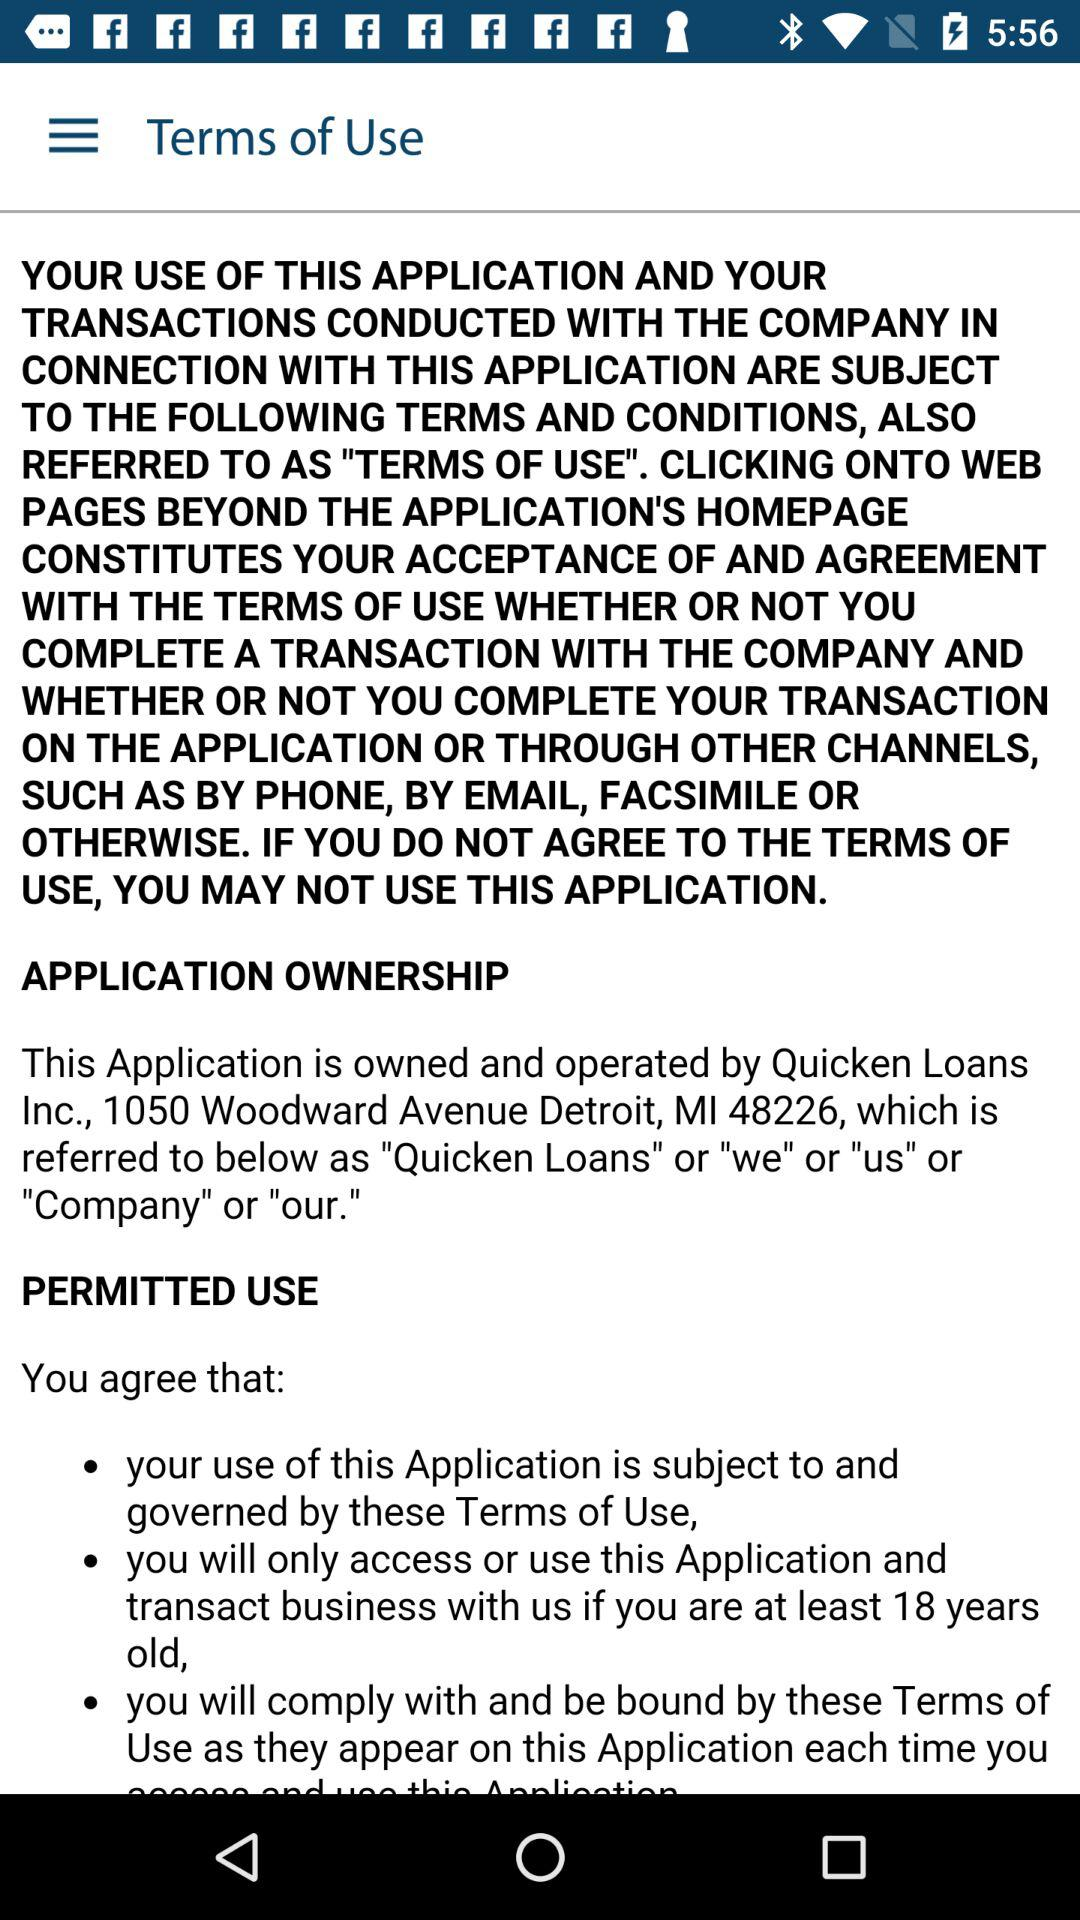How many black dots are there in the page?
Answer the question using a single word or phrase. 3 